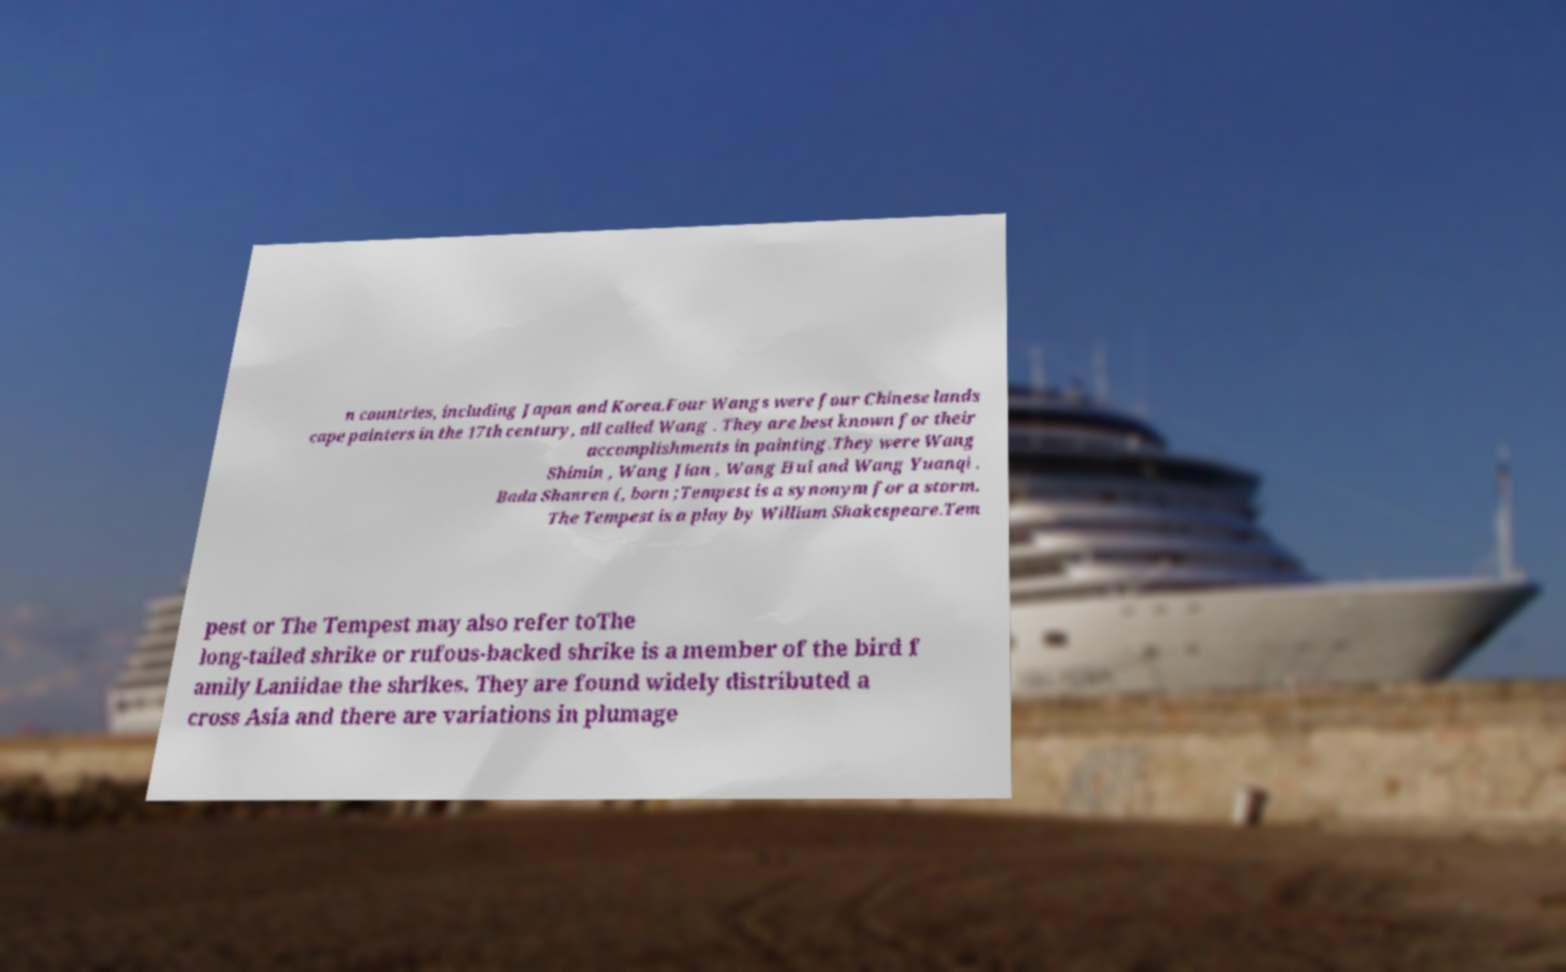Could you assist in decoding the text presented in this image and type it out clearly? n countries, including Japan and Korea.Four Wangs were four Chinese lands cape painters in the 17th century, all called Wang . They are best known for their accomplishments in painting.They were Wang Shimin , Wang Jian , Wang Hui and Wang Yuanqi . Bada Shanren (, born ;Tempest is a synonym for a storm. The Tempest is a play by William Shakespeare.Tem pest or The Tempest may also refer toThe long-tailed shrike or rufous-backed shrike is a member of the bird f amily Laniidae the shrikes. They are found widely distributed a cross Asia and there are variations in plumage 